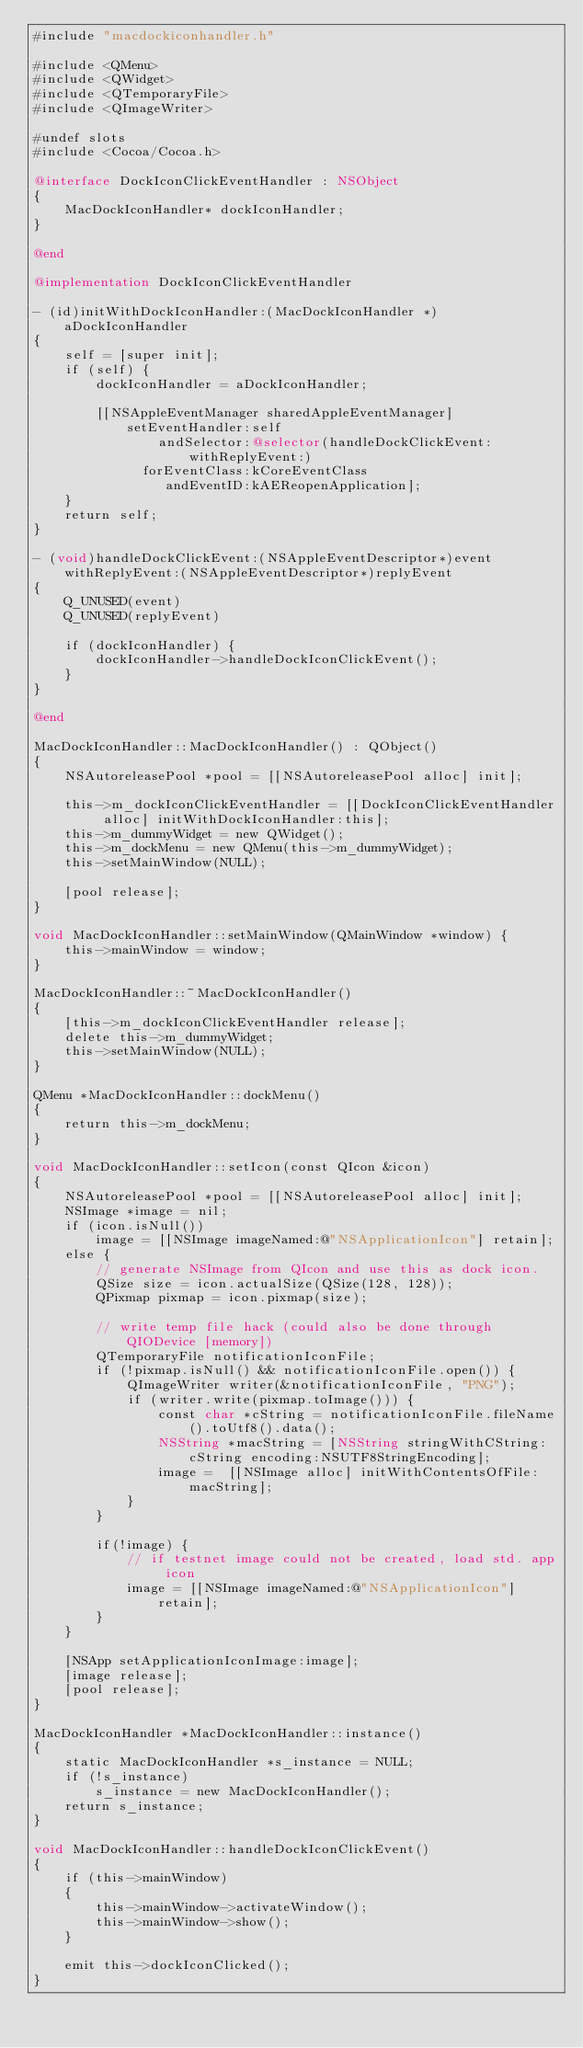Convert code to text. <code><loc_0><loc_0><loc_500><loc_500><_ObjectiveC_>#include "macdockiconhandler.h"

#include <QMenu>
#include <QWidget>
#include <QTemporaryFile>
#include <QImageWriter>

#undef slots
#include <Cocoa/Cocoa.h>

@interface DockIconClickEventHandler : NSObject
{
    MacDockIconHandler* dockIconHandler;
}

@end

@implementation DockIconClickEventHandler

- (id)initWithDockIconHandler:(MacDockIconHandler *)aDockIconHandler
{
    self = [super init];
    if (self) {
        dockIconHandler = aDockIconHandler;

        [[NSAppleEventManager sharedAppleEventManager]
            setEventHandler:self
                andSelector:@selector(handleDockClickEvent:withReplyEvent:)
              forEventClass:kCoreEventClass
                 andEventID:kAEReopenApplication];
    }
    return self;
}

- (void)handleDockClickEvent:(NSAppleEventDescriptor*)event withReplyEvent:(NSAppleEventDescriptor*)replyEvent
{
    Q_UNUSED(event)
    Q_UNUSED(replyEvent)

    if (dockIconHandler) {
        dockIconHandler->handleDockIconClickEvent();
    }
}

@end

MacDockIconHandler::MacDockIconHandler() : QObject()
{
    NSAutoreleasePool *pool = [[NSAutoreleasePool alloc] init];

    this->m_dockIconClickEventHandler = [[DockIconClickEventHandler alloc] initWithDockIconHandler:this];
    this->m_dummyWidget = new QWidget();
    this->m_dockMenu = new QMenu(this->m_dummyWidget);
    this->setMainWindow(NULL);

    [pool release];
}

void MacDockIconHandler::setMainWindow(QMainWindow *window) {
    this->mainWindow = window;
}

MacDockIconHandler::~MacDockIconHandler()
{
    [this->m_dockIconClickEventHandler release];
    delete this->m_dummyWidget;
    this->setMainWindow(NULL);
}

QMenu *MacDockIconHandler::dockMenu()
{
    return this->m_dockMenu;
}

void MacDockIconHandler::setIcon(const QIcon &icon)
{
    NSAutoreleasePool *pool = [[NSAutoreleasePool alloc] init];
    NSImage *image = nil;
    if (icon.isNull())
        image = [[NSImage imageNamed:@"NSApplicationIcon"] retain];
    else {
        // generate NSImage from QIcon and use this as dock icon.
        QSize size = icon.actualSize(QSize(128, 128));
        QPixmap pixmap = icon.pixmap(size);

        // write temp file hack (could also be done through QIODevice [memory])
        QTemporaryFile notificationIconFile;
        if (!pixmap.isNull() && notificationIconFile.open()) {
            QImageWriter writer(&notificationIconFile, "PNG");
            if (writer.write(pixmap.toImage())) {
                const char *cString = notificationIconFile.fileName().toUtf8().data();
                NSString *macString = [NSString stringWithCString:cString encoding:NSUTF8StringEncoding];
                image =  [[NSImage alloc] initWithContentsOfFile:macString];
            }
        }

        if(!image) {
            // if testnet image could not be created, load std. app icon
            image = [[NSImage imageNamed:@"NSApplicationIcon"] retain];
        }
    }

    [NSApp setApplicationIconImage:image];
    [image release];
    [pool release];
}

MacDockIconHandler *MacDockIconHandler::instance()
{
    static MacDockIconHandler *s_instance = NULL;
    if (!s_instance)
        s_instance = new MacDockIconHandler();
    return s_instance;
}

void MacDockIconHandler::handleDockIconClickEvent()
{
    if (this->mainWindow)
    {
        this->mainWindow->activateWindow();
        this->mainWindow->show();
    }

    emit this->dockIconClicked();
}
</code> 